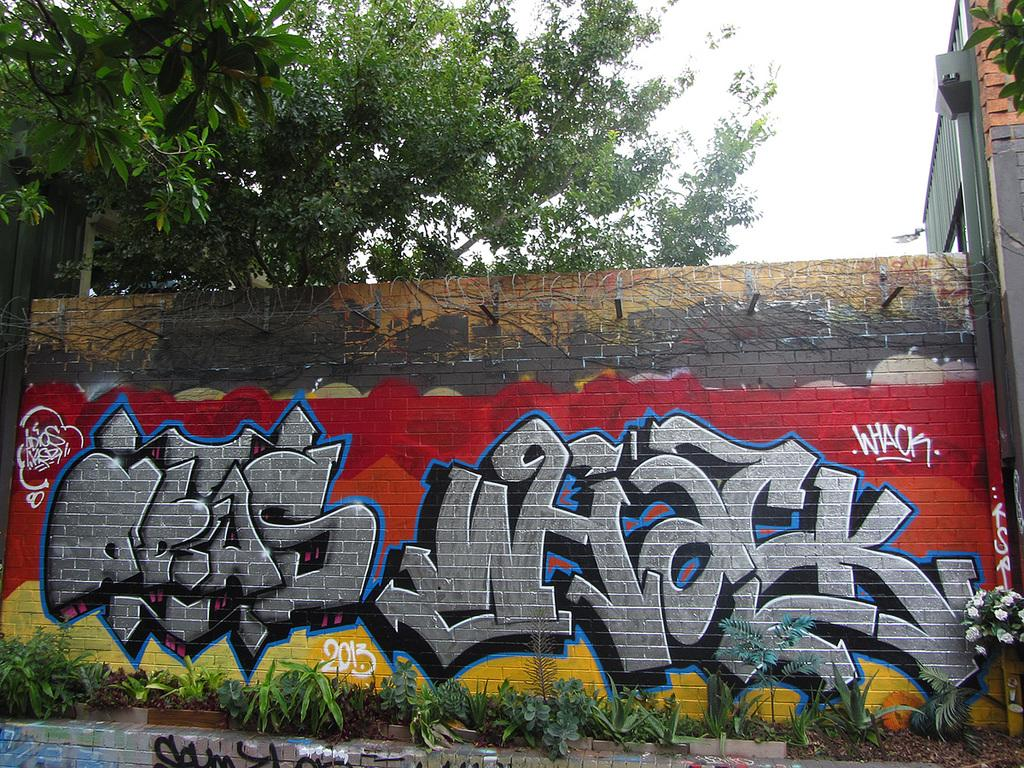What is on the wall in the image? There is graffiti on the wall in the image. What can be seen in the background of the image? There is a group of plants, trees, a building, and the sky visible in the background of the image. What type of toys can be seen on the stage in the image? There is no stage or toys present in the image. What color is the button on the graffiti in the image? There is no button on the graffiti in the image. 